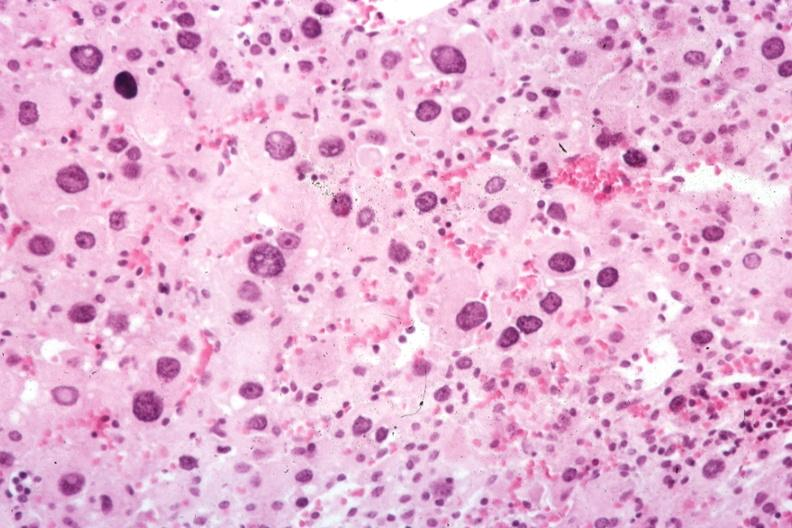does atherosclerosis show typical cells?
Answer the question using a single word or phrase. No 